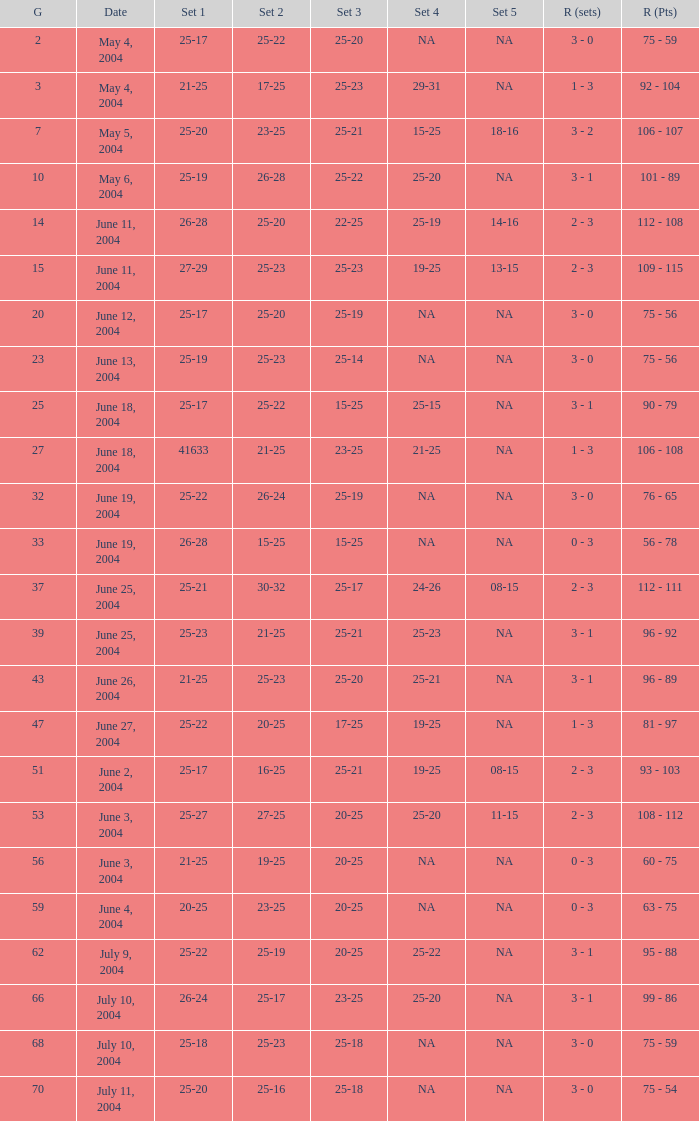What is the result of the game with a set 1 of 26-24? 99 - 86. 